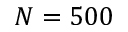<formula> <loc_0><loc_0><loc_500><loc_500>N = 5 0 0</formula> 